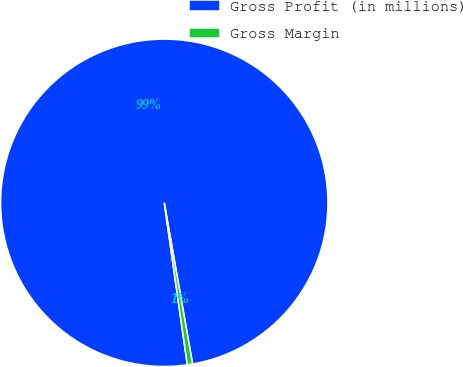<chart> <loc_0><loc_0><loc_500><loc_500><pie_chart><fcel>Gross Profit (in millions)<fcel>Gross Margin<nl><fcel>99.48%<fcel>0.52%<nl></chart> 